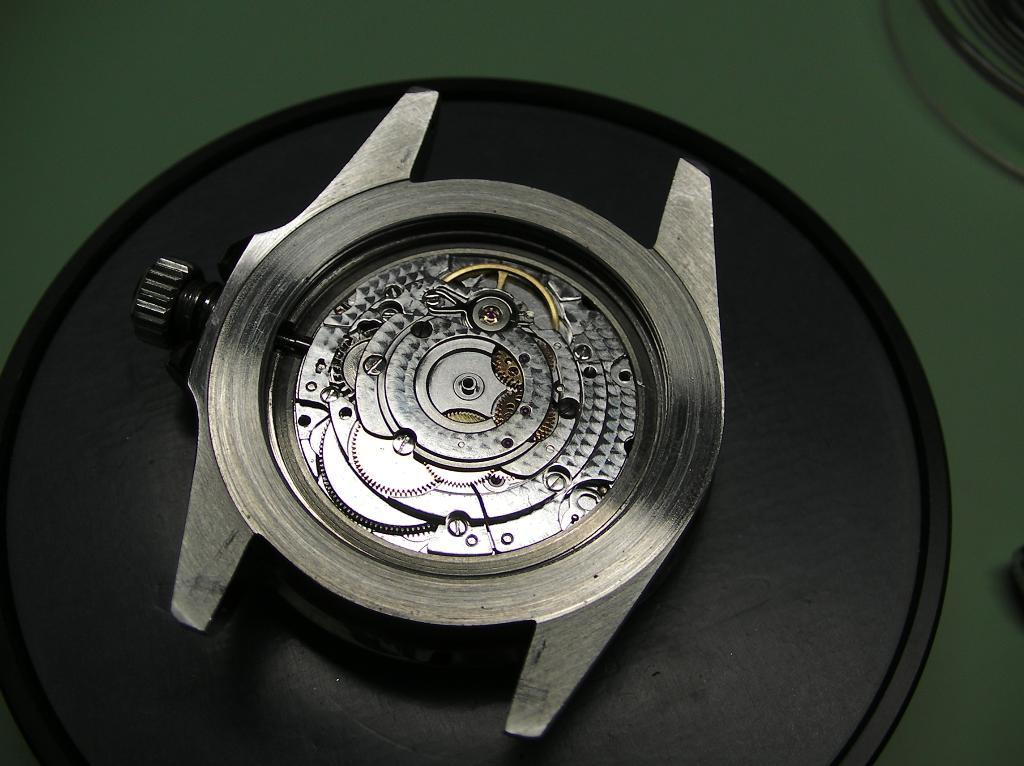What is the main subject of the image? The main subject of the image is the dial of a watch. Can you describe the location of the watch dial in the image? The dial of the watch is on an object. What type of silk fabric is draped over the can in the bedroom in the image? There is no mention of a bedroom, silk fabric, or can in the image. The image only features the dial of a watch on an object. 